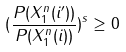<formula> <loc_0><loc_0><loc_500><loc_500>( \frac { P ( X _ { 1 } ^ { n } ( i ^ { \prime } ) ) } { P ( X _ { 1 } ^ { n } ( i ) ) } ) ^ { s } \geq 0</formula> 